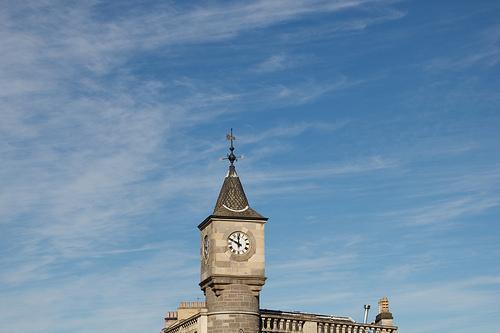How many red birds are in the image?
Give a very brief answer. 0. 